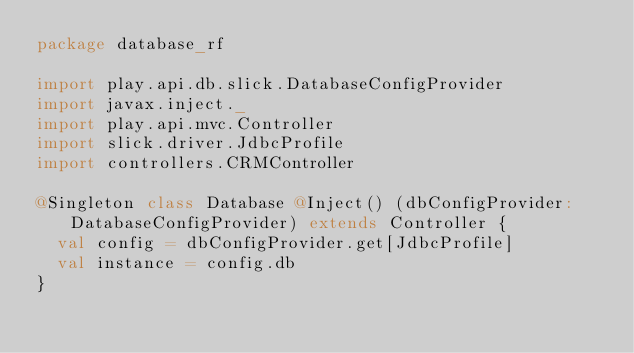Convert code to text. <code><loc_0><loc_0><loc_500><loc_500><_Scala_>package database_rf

import play.api.db.slick.DatabaseConfigProvider
import javax.inject._
import play.api.mvc.Controller
import slick.driver.JdbcProfile
import controllers.CRMController

@Singleton class Database @Inject() (dbConfigProvider: DatabaseConfigProvider) extends Controller {
  val config = dbConfigProvider.get[JdbcProfile]
  val instance = config.db
}</code> 